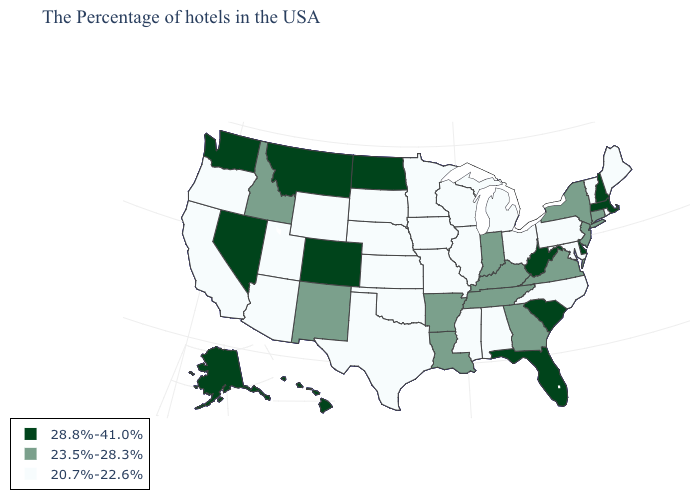Which states have the lowest value in the USA?
Answer briefly. Maine, Rhode Island, Vermont, Maryland, Pennsylvania, North Carolina, Ohio, Michigan, Alabama, Wisconsin, Illinois, Mississippi, Missouri, Minnesota, Iowa, Kansas, Nebraska, Oklahoma, Texas, South Dakota, Wyoming, Utah, Arizona, California, Oregon. Does West Virginia have the same value as New Hampshire?
Keep it brief. Yes. Name the states that have a value in the range 23.5%-28.3%?
Be succinct. Connecticut, New York, New Jersey, Virginia, Georgia, Kentucky, Indiana, Tennessee, Louisiana, Arkansas, New Mexico, Idaho. Which states have the lowest value in the USA?
Be succinct. Maine, Rhode Island, Vermont, Maryland, Pennsylvania, North Carolina, Ohio, Michigan, Alabama, Wisconsin, Illinois, Mississippi, Missouri, Minnesota, Iowa, Kansas, Nebraska, Oklahoma, Texas, South Dakota, Wyoming, Utah, Arizona, California, Oregon. Which states hav the highest value in the Northeast?
Short answer required. Massachusetts, New Hampshire. What is the highest value in states that border Minnesota?
Concise answer only. 28.8%-41.0%. What is the highest value in the USA?
Short answer required. 28.8%-41.0%. Does North Dakota have a lower value than Mississippi?
Answer briefly. No. Name the states that have a value in the range 23.5%-28.3%?
Write a very short answer. Connecticut, New York, New Jersey, Virginia, Georgia, Kentucky, Indiana, Tennessee, Louisiana, Arkansas, New Mexico, Idaho. What is the highest value in the Northeast ?
Be succinct. 28.8%-41.0%. What is the highest value in the USA?
Concise answer only. 28.8%-41.0%. Is the legend a continuous bar?
Write a very short answer. No. What is the value of New Jersey?
Quick response, please. 23.5%-28.3%. What is the value of Wyoming?
Write a very short answer. 20.7%-22.6%. What is the highest value in the West ?
Be succinct. 28.8%-41.0%. 